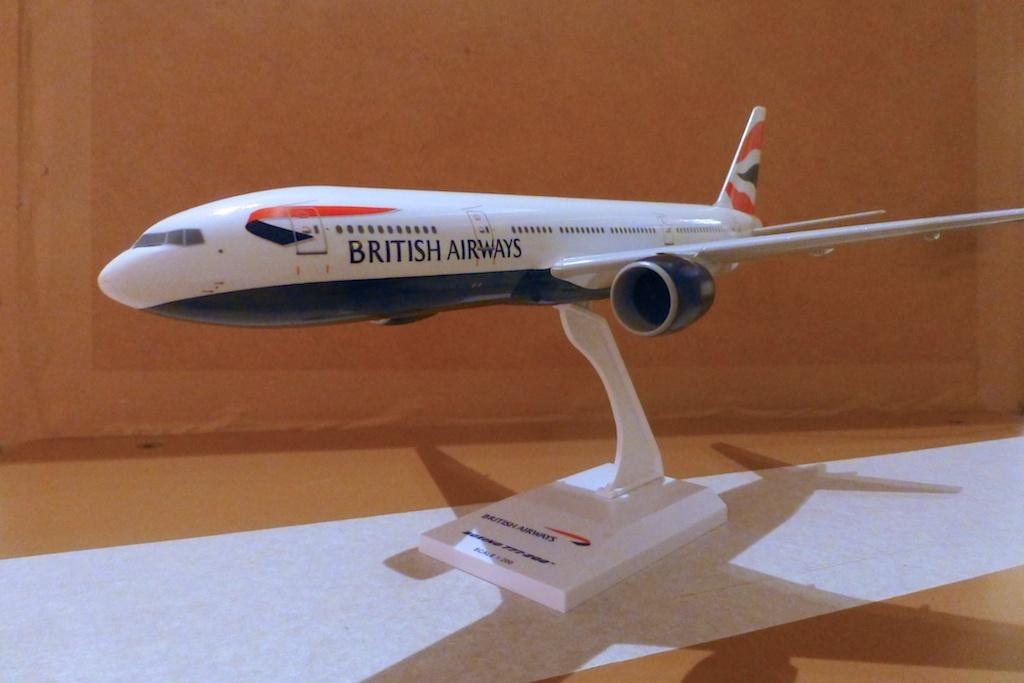<image>
Render a clear and concise summary of the photo. a model of a white red and black british airways airplane. 